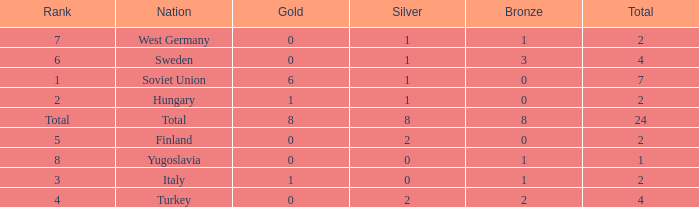What is the total sum when silver equals 0 and gold equals 1? 2.0. 